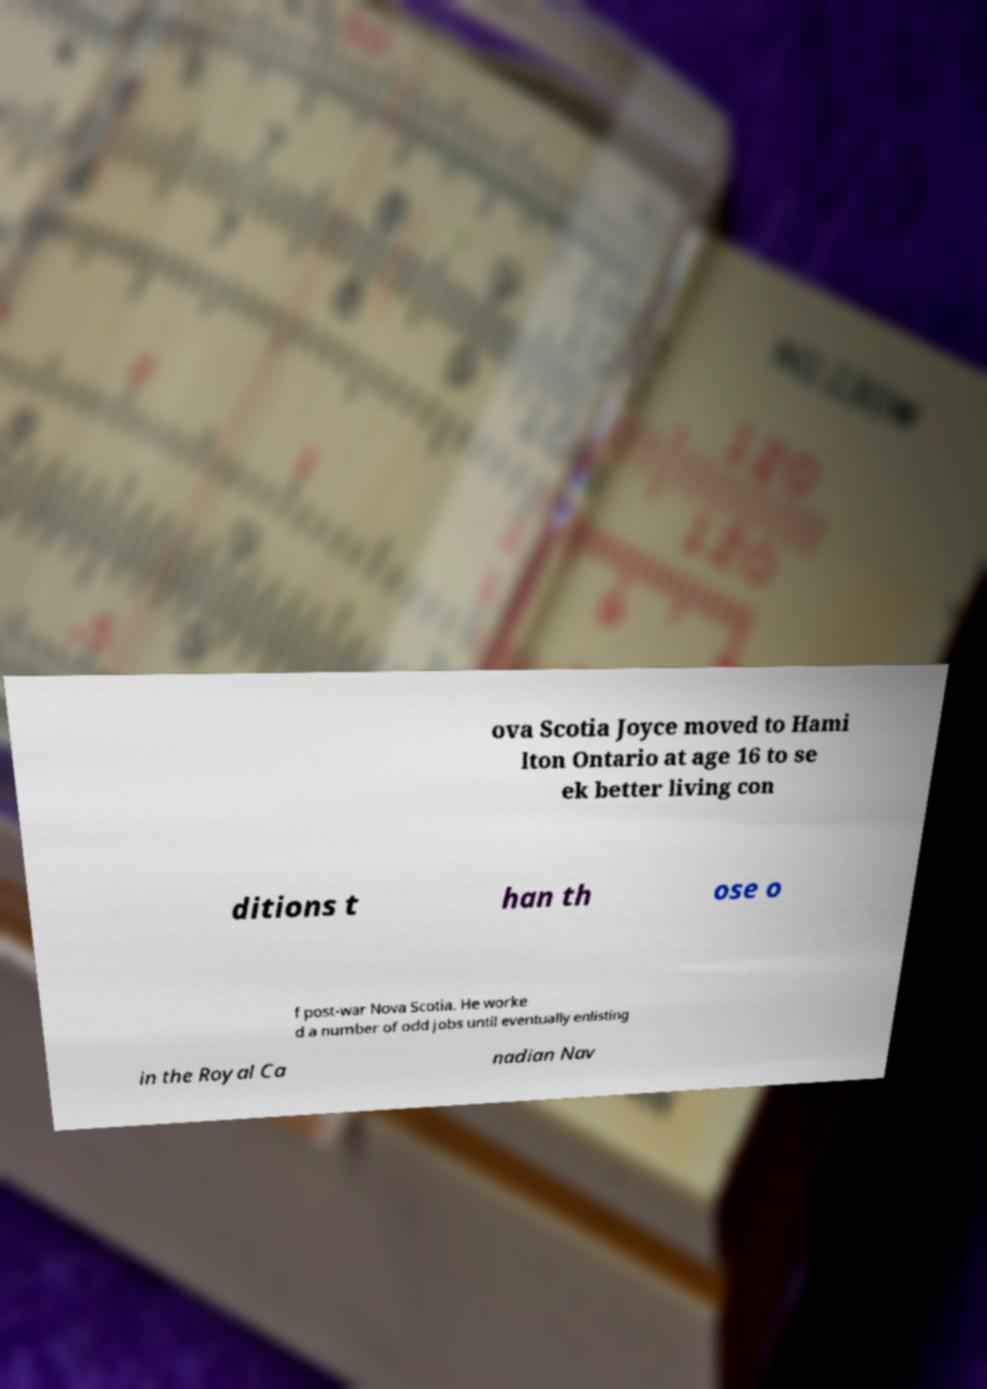There's text embedded in this image that I need extracted. Can you transcribe it verbatim? ova Scotia Joyce moved to Hami lton Ontario at age 16 to se ek better living con ditions t han th ose o f post-war Nova Scotia. He worke d a number of odd jobs until eventually enlisting in the Royal Ca nadian Nav 